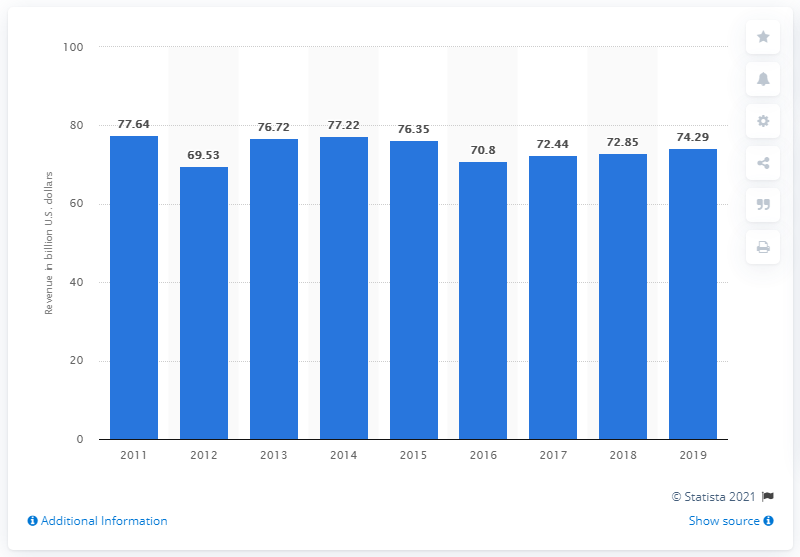Highlight a few significant elements in this photo. In 2019, Citigroup's global revenue was 74.29 billion U.S. dollars. 